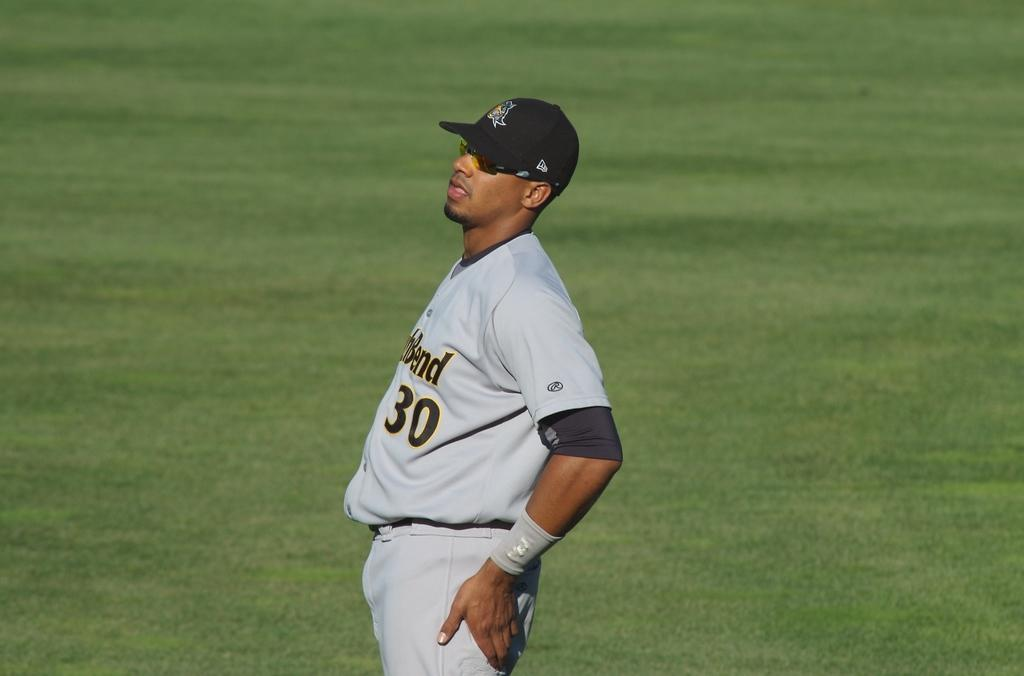<image>
Create a compact narrative representing the image presented. A man in a gray and black baseball uniform with the number 30 on his mid section is stretching. 